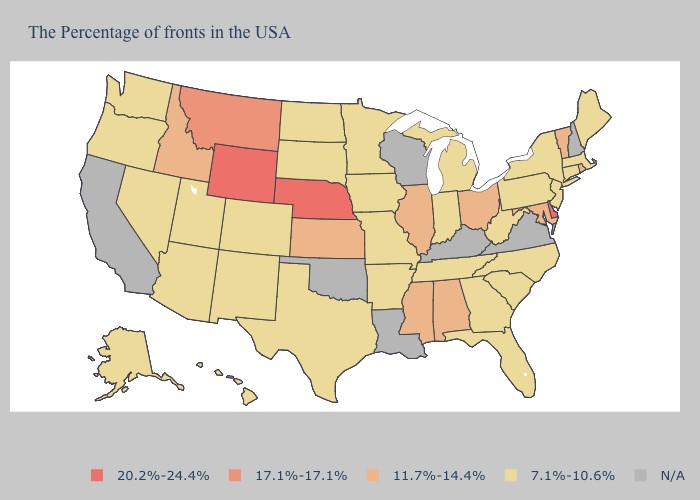What is the highest value in states that border Massachusetts?
Keep it brief. 11.7%-14.4%. Does Michigan have the highest value in the USA?
Be succinct. No. Name the states that have a value in the range 11.7%-14.4%?
Answer briefly. Rhode Island, Vermont, Maryland, Ohio, Alabama, Illinois, Mississippi, Kansas, Idaho. Does Georgia have the lowest value in the South?
Short answer required. Yes. What is the value of Kentucky?
Short answer required. N/A. What is the value of Texas?
Write a very short answer. 7.1%-10.6%. What is the value of Kentucky?
Quick response, please. N/A. Name the states that have a value in the range 17.1%-17.1%?
Be succinct. Montana. Does New Jersey have the highest value in the Northeast?
Concise answer only. No. Does Wyoming have the highest value in the USA?
Give a very brief answer. Yes. What is the value of Ohio?
Concise answer only. 11.7%-14.4%. Which states have the highest value in the USA?
Give a very brief answer. Delaware, Nebraska, Wyoming. Does Indiana have the highest value in the USA?
Concise answer only. No. Name the states that have a value in the range N/A?
Quick response, please. New Hampshire, Virginia, Kentucky, Wisconsin, Louisiana, Oklahoma, California. Does Maine have the highest value in the Northeast?
Concise answer only. No. 